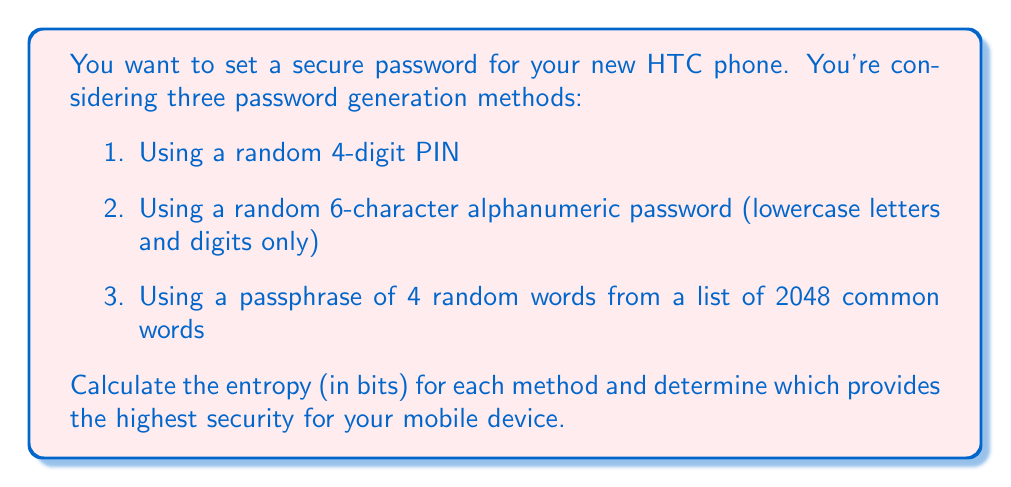What is the answer to this math problem? To calculate the entropy of each password generation method, we use the formula:

$$ E = \log_2(N^L) $$

Where $E$ is the entropy in bits, $N$ is the number of possible symbols in each position, and $L$ is the length of the password.

1. For the 4-digit PIN:
   $N = 10$ (digits 0-9)
   $L = 4$
   $$ E_1 = \log_2(10^4) = \log_2(10000) \approx 13.29 \text{ bits} $$

2. For the 6-character alphanumeric password:
   $N = 36$ (26 lowercase letters + 10 digits)
   $L = 6$
   $$ E_2 = \log_2(36^6) = \log_2(2,176,782,336) \approx 31.02 \text{ bits} $$

3. For the 4-word passphrase:
   $N = 2048$ (number of words in the list)
   $L = 4$
   $$ E_3 = \log_2(2048^4) = \log_2(17,592,186,044,416) \approx 44 \text{ bits} $$

Comparing the results:
$E_1 \approx 13.29 \text{ bits}$
$E_2 \approx 31.02 \text{ bits}$
$E_3 = 44 \text{ bits}$

The 4-word passphrase (method 3) provides the highest entropy and therefore the highest security for your mobile device.
Answer: 44 bits (4-word passphrase) 